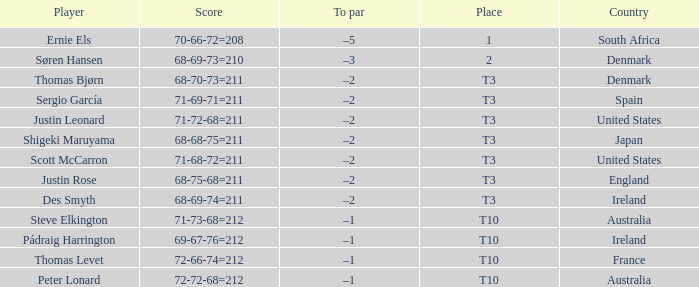What was Australia's score when Peter Lonard played? 72-72-68=212. 